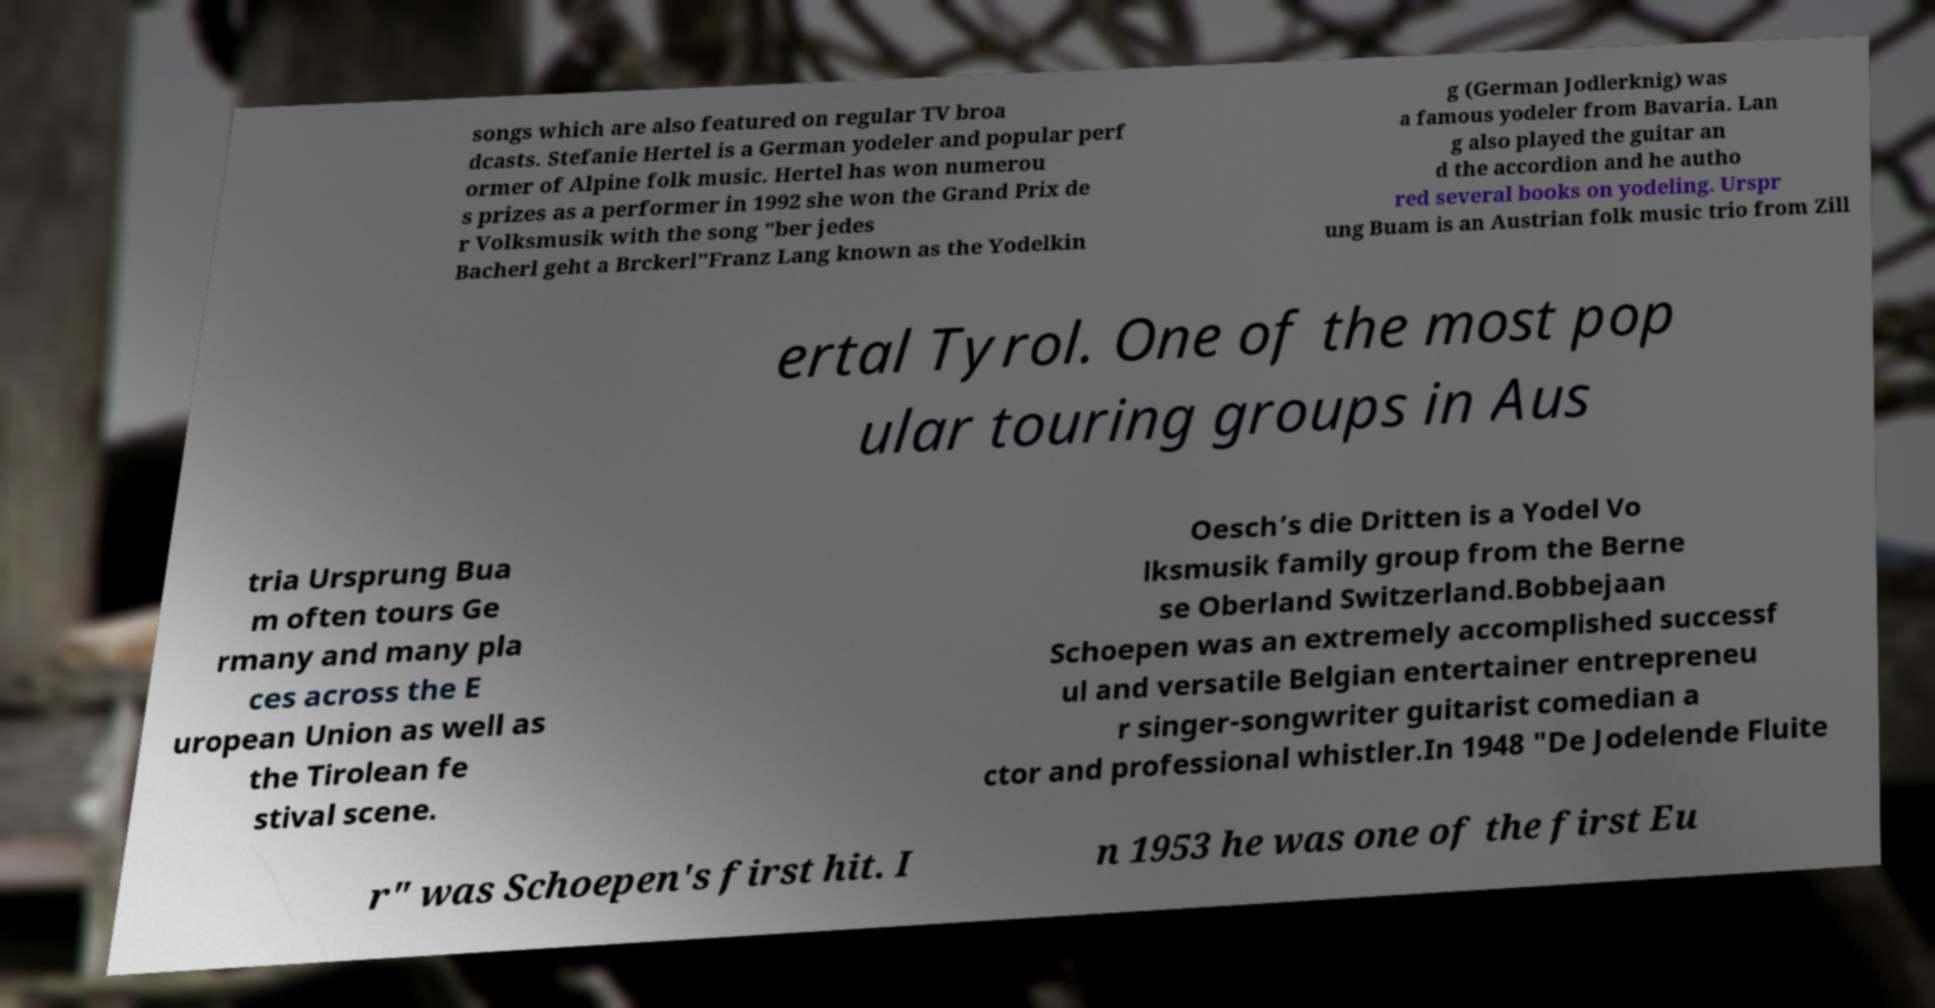I need the written content from this picture converted into text. Can you do that? songs which are also featured on regular TV broa dcasts. Stefanie Hertel is a German yodeler and popular perf ormer of Alpine folk music. Hertel has won numerou s prizes as a performer in 1992 she won the Grand Prix de r Volksmusik with the song "ber jedes Bacherl geht a Brckerl"Franz Lang known as the Yodelkin g (German Jodlerknig) was a famous yodeler from Bavaria. Lan g also played the guitar an d the accordion and he autho red several books on yodeling. Urspr ung Buam is an Austrian folk music trio from Zill ertal Tyrol. One of the most pop ular touring groups in Aus tria Ursprung Bua m often tours Ge rmany and many pla ces across the E uropean Union as well as the Tirolean fe stival scene. Oesch’s die Dritten is a Yodel Vo lksmusik family group from the Berne se Oberland Switzerland.Bobbejaan Schoepen was an extremely accomplished successf ul and versatile Belgian entertainer entrepreneu r singer-songwriter guitarist comedian a ctor and professional whistler.In 1948 "De Jodelende Fluite r" was Schoepen's first hit. I n 1953 he was one of the first Eu 